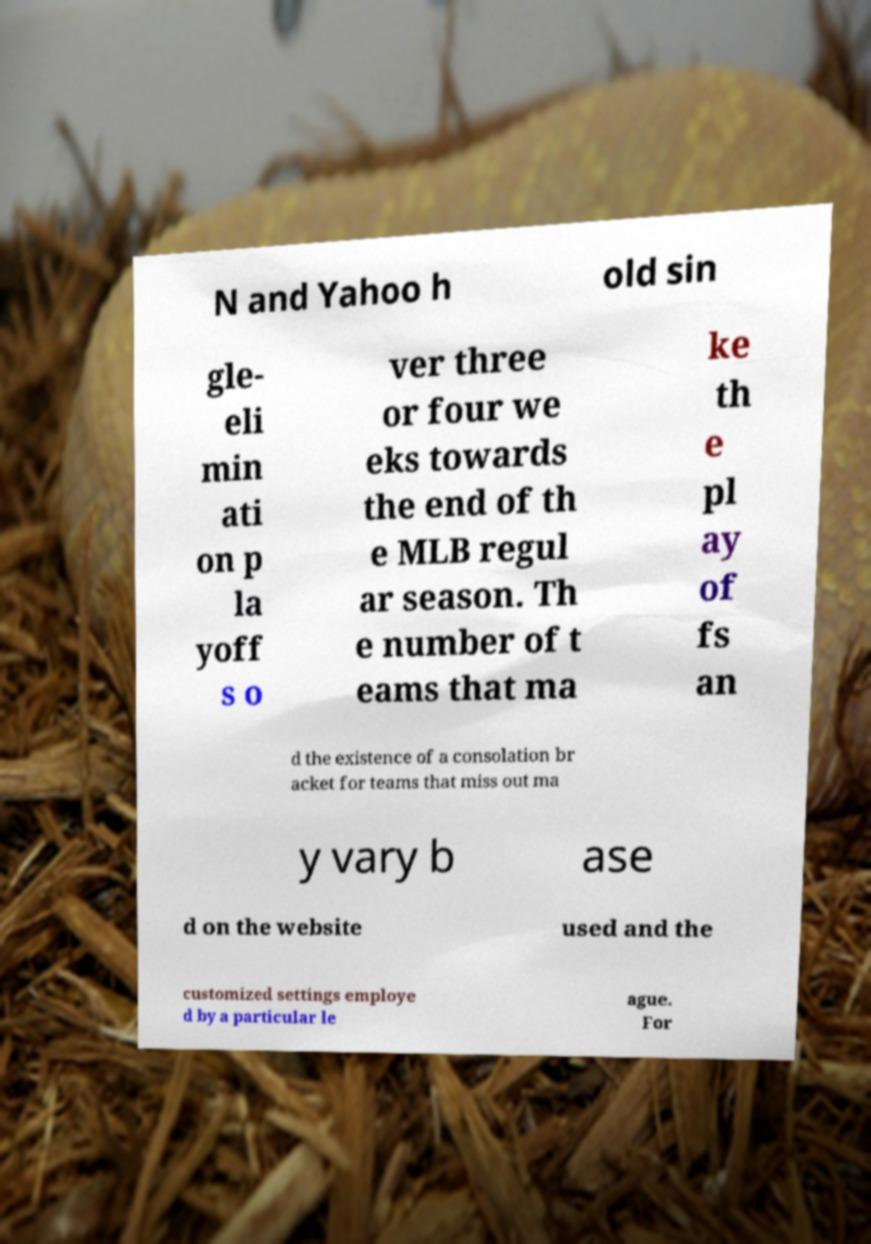Can you accurately transcribe the text from the provided image for me? N and Yahoo h old sin gle- eli min ati on p la yoff s o ver three or four we eks towards the end of th e MLB regul ar season. Th e number of t eams that ma ke th e pl ay of fs an d the existence of a consolation br acket for teams that miss out ma y vary b ase d on the website used and the customized settings employe d by a particular le ague. For 